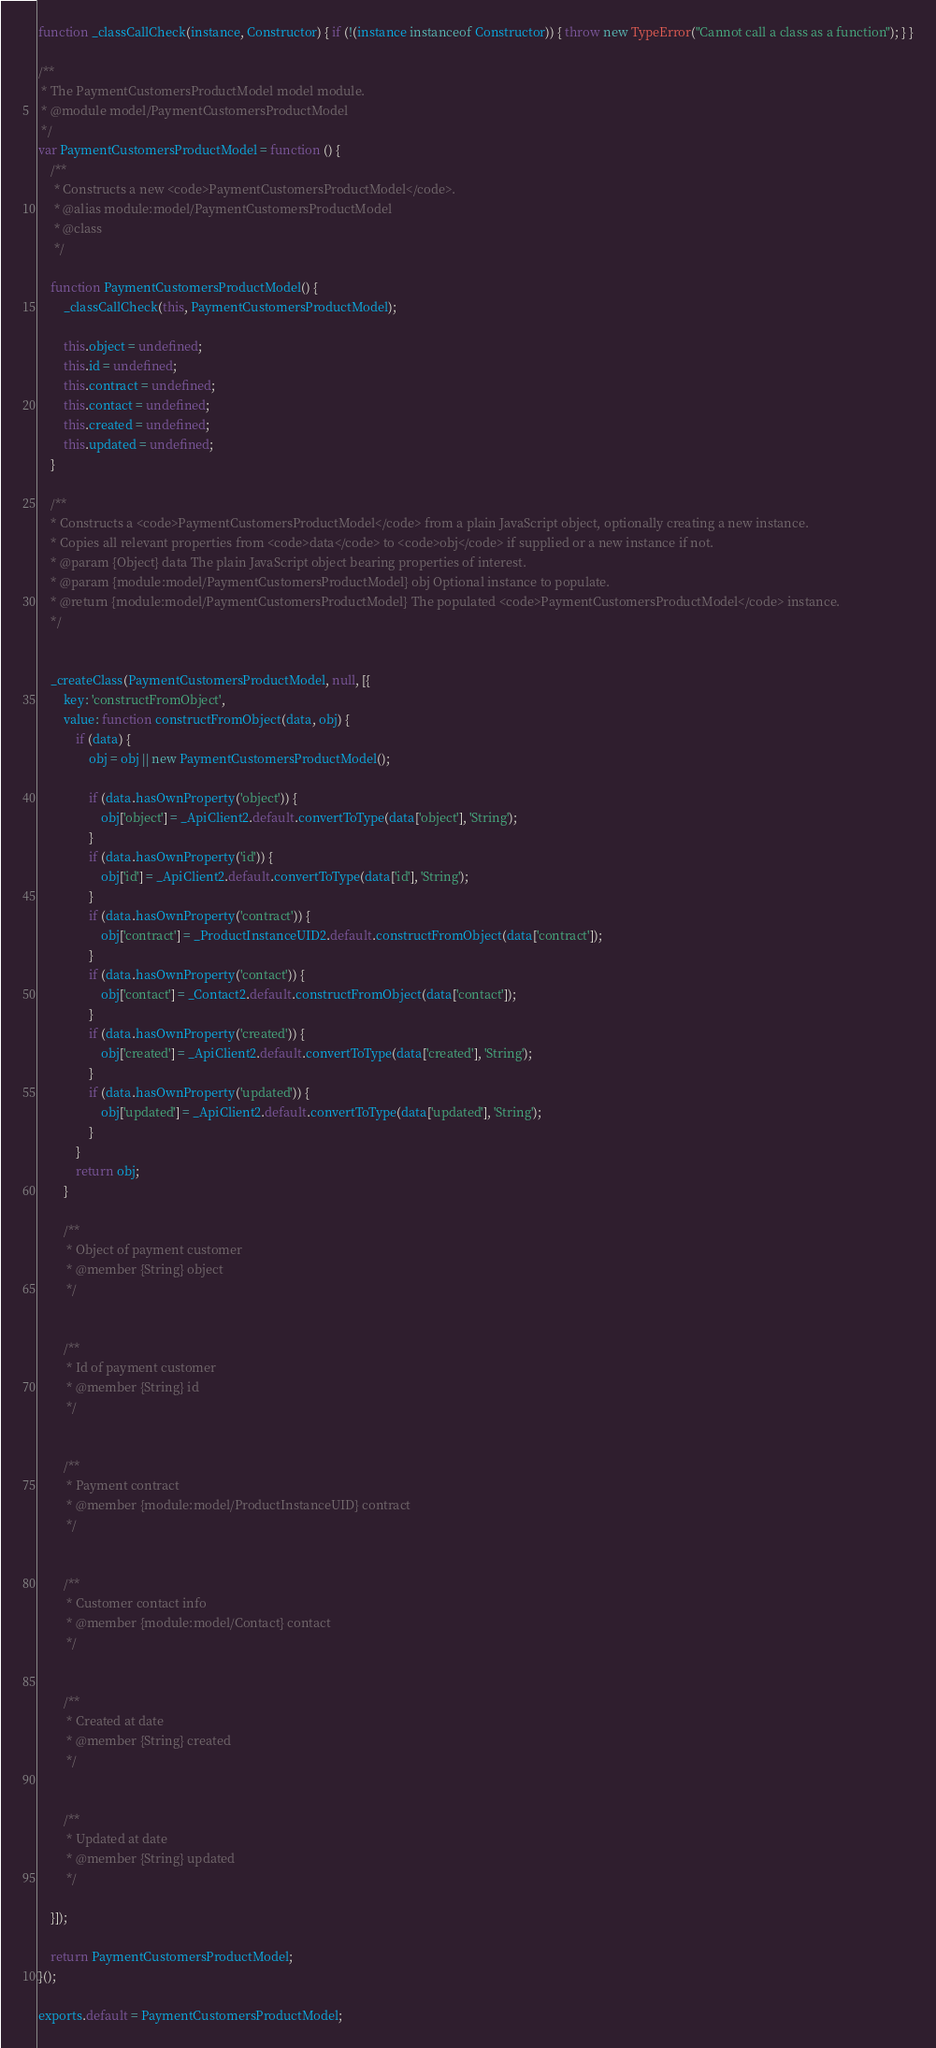<code> <loc_0><loc_0><loc_500><loc_500><_JavaScript_>function _classCallCheck(instance, Constructor) { if (!(instance instanceof Constructor)) { throw new TypeError("Cannot call a class as a function"); } }

/**
 * The PaymentCustomersProductModel model module.
 * @module model/PaymentCustomersProductModel
 */
var PaymentCustomersProductModel = function () {
    /**
     * Constructs a new <code>PaymentCustomersProductModel</code>.
     * @alias module:model/PaymentCustomersProductModel
     * @class
     */

    function PaymentCustomersProductModel() {
        _classCallCheck(this, PaymentCustomersProductModel);

        this.object = undefined;
        this.id = undefined;
        this.contract = undefined;
        this.contact = undefined;
        this.created = undefined;
        this.updated = undefined;
    }

    /**
    * Constructs a <code>PaymentCustomersProductModel</code> from a plain JavaScript object, optionally creating a new instance.
    * Copies all relevant properties from <code>data</code> to <code>obj</code> if supplied or a new instance if not.
    * @param {Object} data The plain JavaScript object bearing properties of interest.
    * @param {module:model/PaymentCustomersProductModel} obj Optional instance to populate.
    * @return {module:model/PaymentCustomersProductModel} The populated <code>PaymentCustomersProductModel</code> instance.
    */


    _createClass(PaymentCustomersProductModel, null, [{
        key: 'constructFromObject',
        value: function constructFromObject(data, obj) {
            if (data) {
                obj = obj || new PaymentCustomersProductModel();

                if (data.hasOwnProperty('object')) {
                    obj['object'] = _ApiClient2.default.convertToType(data['object'], 'String');
                }
                if (data.hasOwnProperty('id')) {
                    obj['id'] = _ApiClient2.default.convertToType(data['id'], 'String');
                }
                if (data.hasOwnProperty('contract')) {
                    obj['contract'] = _ProductInstanceUID2.default.constructFromObject(data['contract']);
                }
                if (data.hasOwnProperty('contact')) {
                    obj['contact'] = _Contact2.default.constructFromObject(data['contact']);
                }
                if (data.hasOwnProperty('created')) {
                    obj['created'] = _ApiClient2.default.convertToType(data['created'], 'String');
                }
                if (data.hasOwnProperty('updated')) {
                    obj['updated'] = _ApiClient2.default.convertToType(data['updated'], 'String');
                }
            }
            return obj;
        }

        /**
         * Object of payment customer
         * @member {String} object
         */


        /**
         * Id of payment customer
         * @member {String} id
         */


        /**
         * Payment contract
         * @member {module:model/ProductInstanceUID} contract
         */


        /**
         * Customer contact info
         * @member {module:model/Contact} contact
         */


        /**
         * Created at date
         * @member {String} created
         */


        /**
         * Updated at date
         * @member {String} updated
         */

    }]);

    return PaymentCustomersProductModel;
}();

exports.default = PaymentCustomersProductModel;</code> 